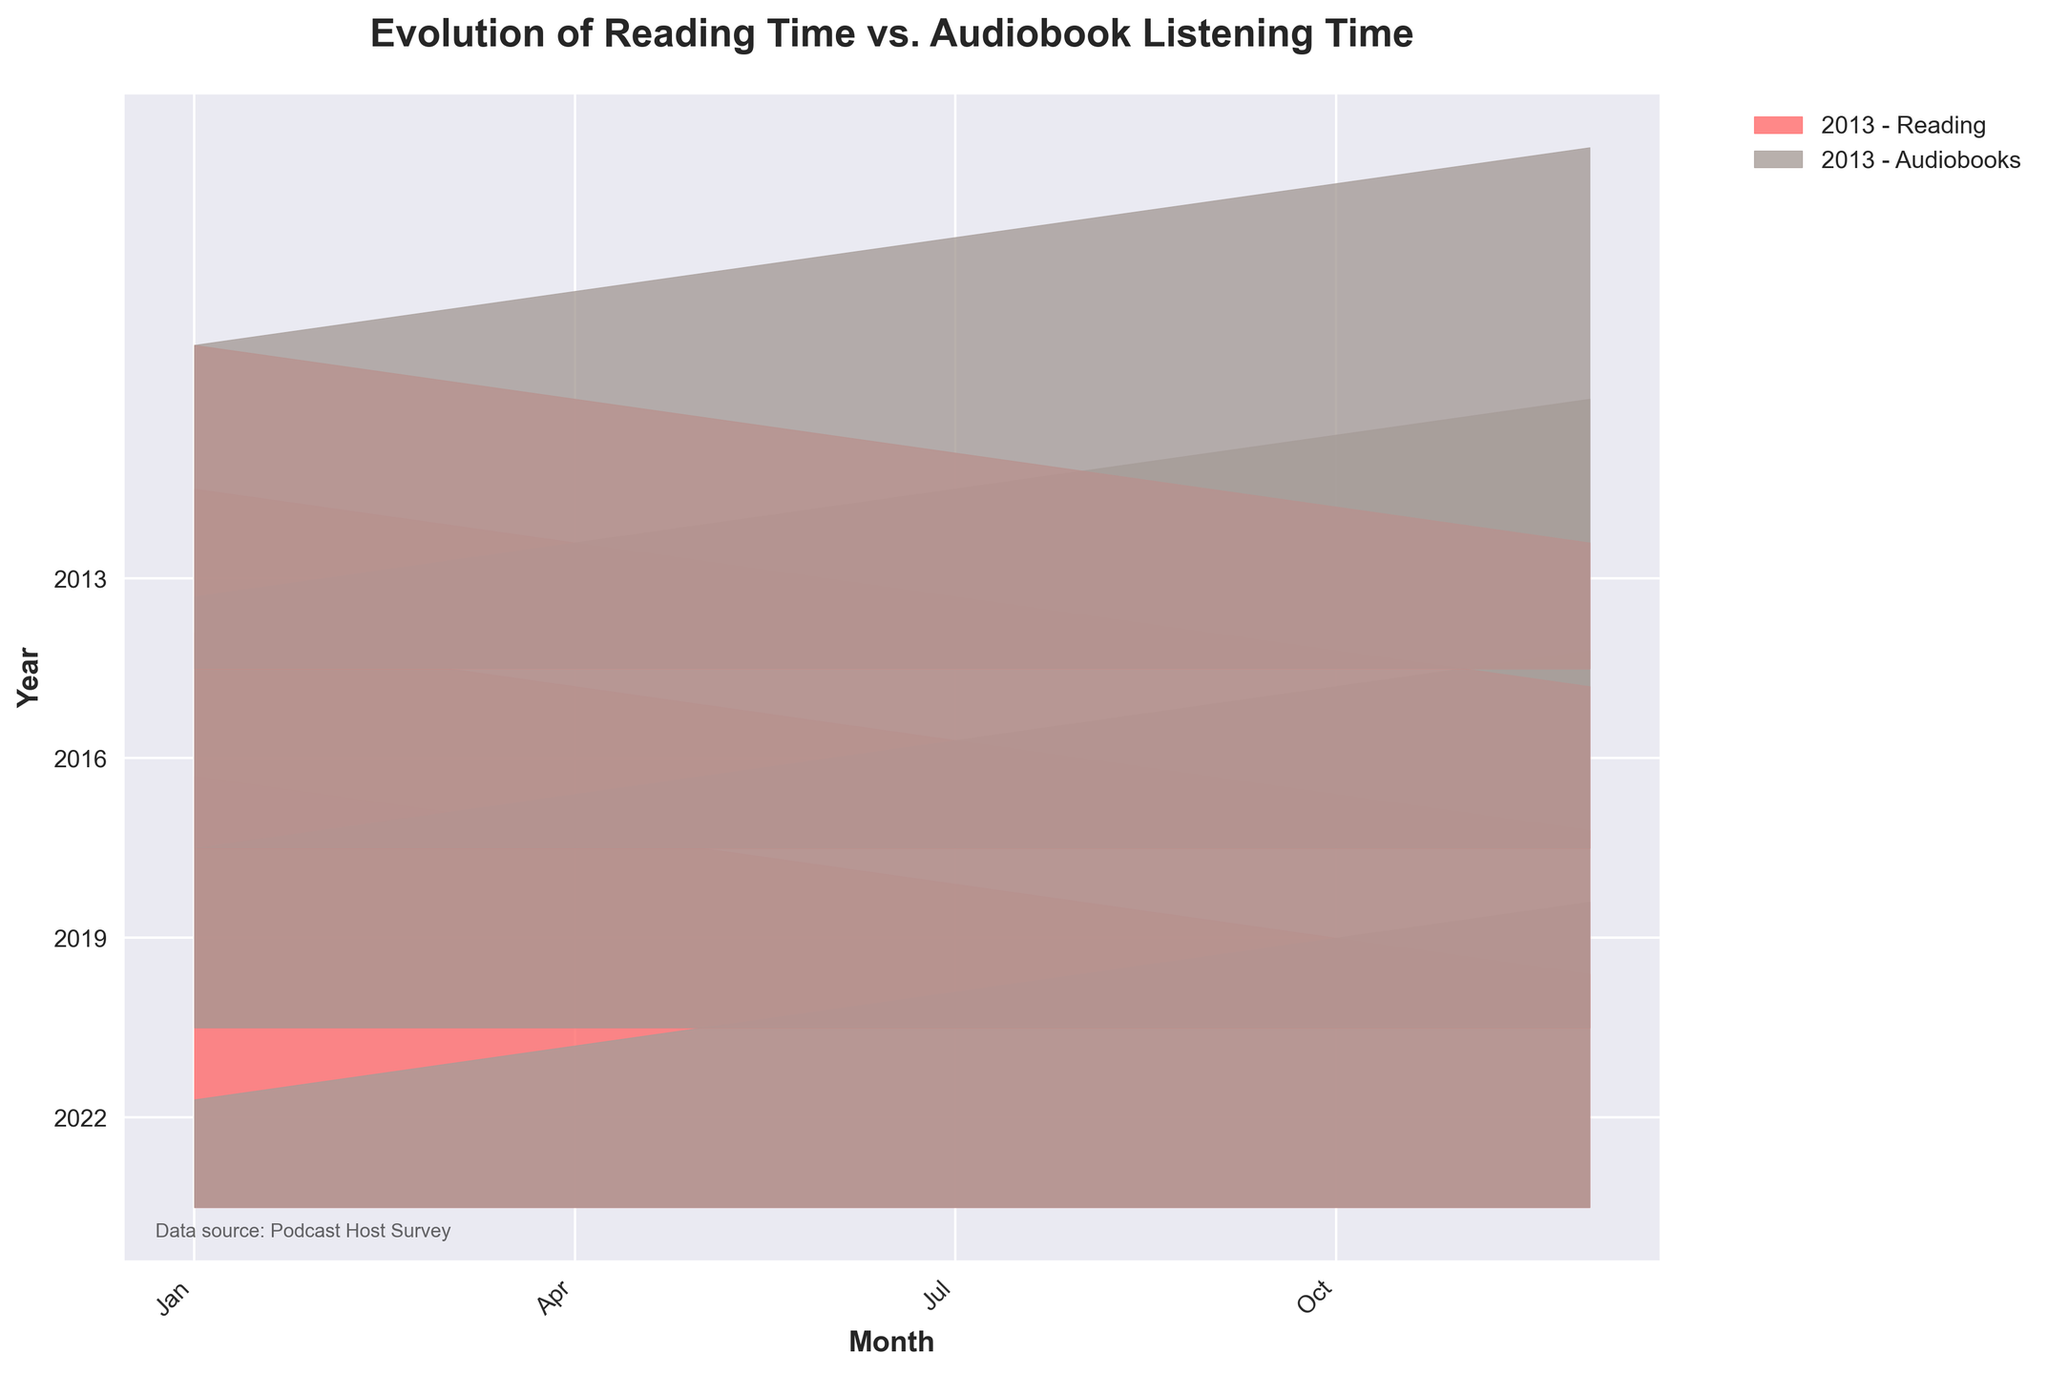What is the overall trend of reading time from 2013 to 2022? The ridgeline plot shows a general decrease in reading time from 2013 to 2022. In 2013, reading time is highest, while it is lowest in 2022. Each year shows a lower plot fill for reading as the years progress.
Answer: Decreasing How did audiobook listening time in 2022 compare to 2013? In 2013, audiobook listening time starts at a lower level and increases to about mid-level. In 2022, it starts at a much higher value and continues to increase throughout the year, reaching the highest values among all years.
Answer: Higher Which medium saw a greater change in usage from 2013 to 2022? We take the difference in usage for both media. For reading, the usage significantly decreased from 2013 to 2022. For audiobooks, the usage drastically increased over the same period, indicating a greater change for audiobooks.
Answer: Audiobooks During which year did audiobook listening time first surpass reading time? By examining the plot, in 2019, the audiobook listening time ridge starts to show higher values than the reading time ridge, indicating that this is the first year audiobook listening time surpassed reading time.
Answer: 2019 What month shows the greatest disparity between reading time and audiobook listening time in 2022? By examining the height of the ridgelines in 2022, December shows the greatest difference, with audiobook listening time reaching much higher values compared to reading time, which is very low.
Answer: December Which year shows the smallest difference between the reading and audiobook listening times? The plot shows that in 2016, the ridges for both reading and audiobooks are closest to each other throughout the months compared to other years.
Answer: 2016 What can be inferred about the popularity of audiobooks in recent years compared to traditional reading? The plot indicates a significant rise in audiobook listening time from 2013 to 2022, while reading time steadily declines, inferring audiobooks have become more popular over traditional reading.
Answer: Audiobooks more popular How does the seasonal trend in audiobook listening time in 2022 compare to reading time in the same year? Both mediums increase throughout the year, but audiobook listening time increases at a greater rate and reaches much higher values than reading time, which shows a modest rise.
Answer: Audiobooks increase more What is the overall pattern of reading and audiobook time throughout a single year? Within each year, reading time generally decreases from January to December, while audiobook listening time shows an upward trend through the months.
Answer: Reading decreases, audiobooks increase How does the overall change in reading time from 2013 to 2022 compare with the change in audiobook listening time over the same period? From 2013 to 2022, reading time significantly decreases while audiobook listening time significantly increases, showing an inverse relationship between the two media.
Answer: Inverse relationship 